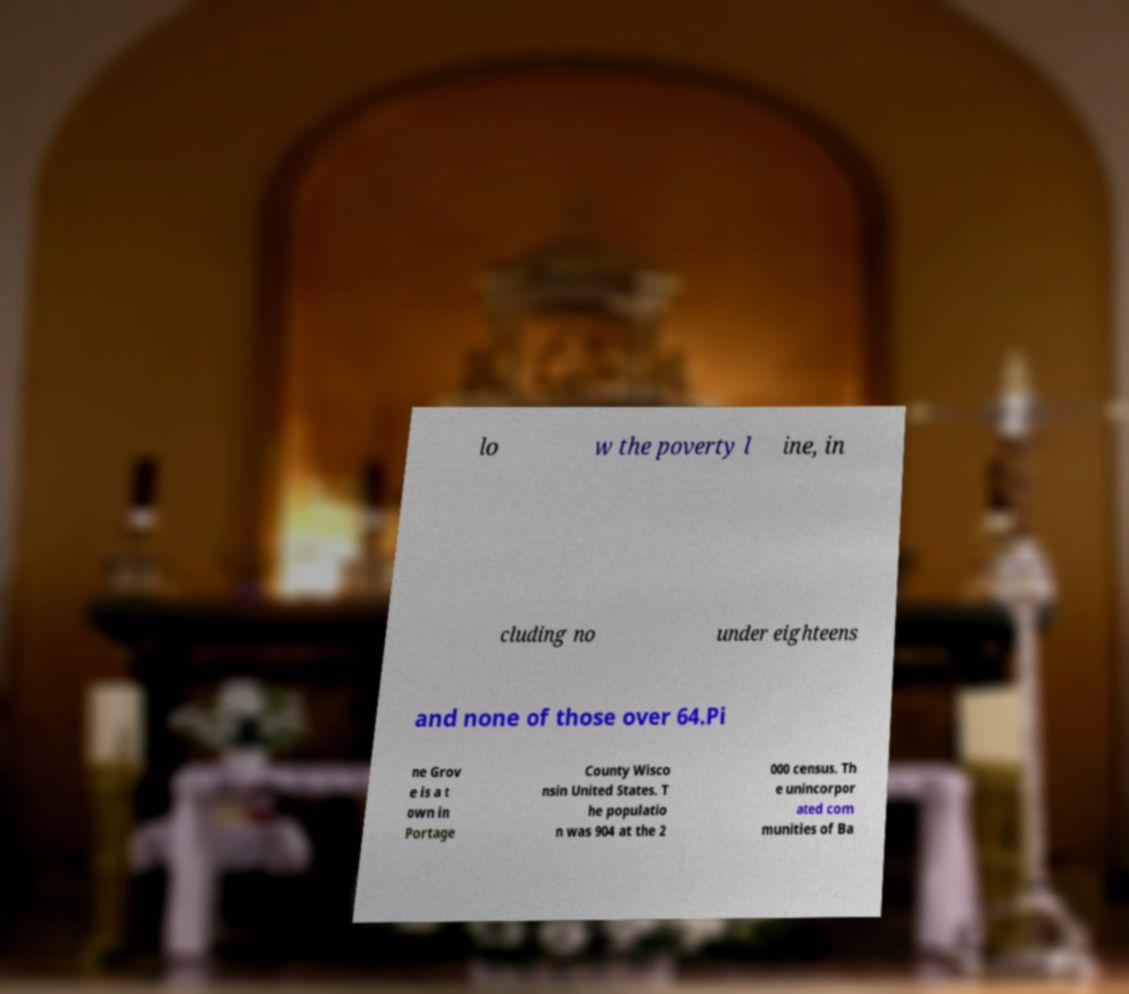For documentation purposes, I need the text within this image transcribed. Could you provide that? lo w the poverty l ine, in cluding no under eighteens and none of those over 64.Pi ne Grov e is a t own in Portage County Wisco nsin United States. T he populatio n was 904 at the 2 000 census. Th e unincorpor ated com munities of Ba 